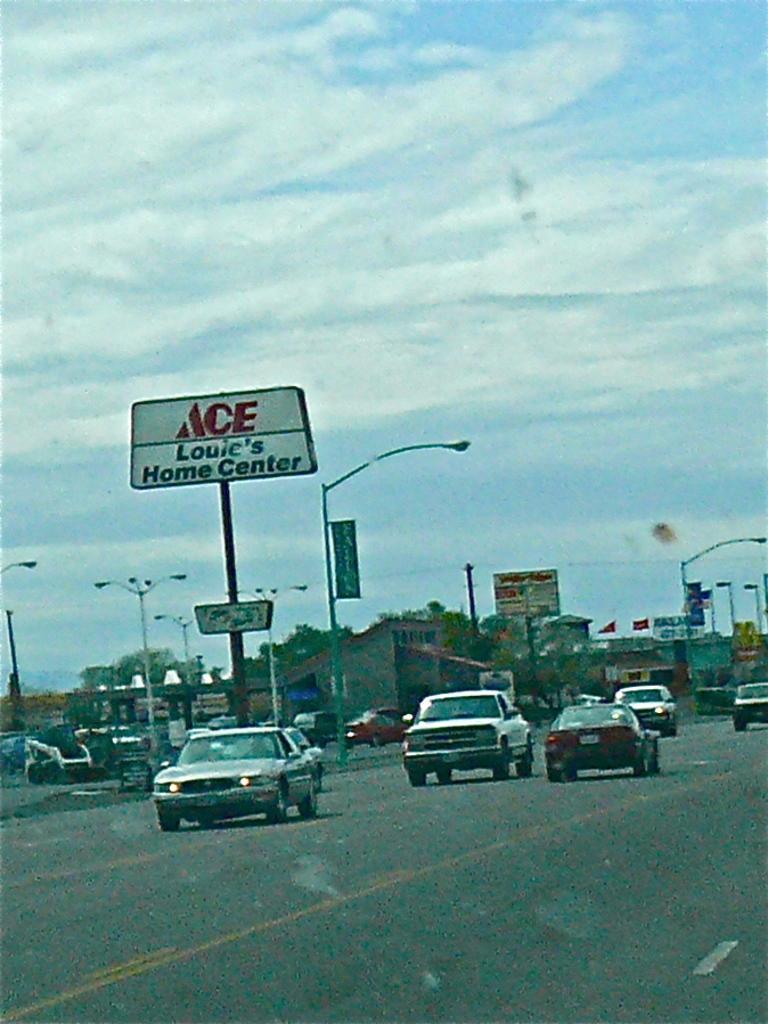How would you summarize this image in a sentence or two? This image is taken outdoors. At the bottom of the image there is a road. At the top of the image there is a sky with clouds. In the middle of the image a few cars are moving on the road. There are a few trees, street lights, poles, signboards, flags and a few boards with text on them. 